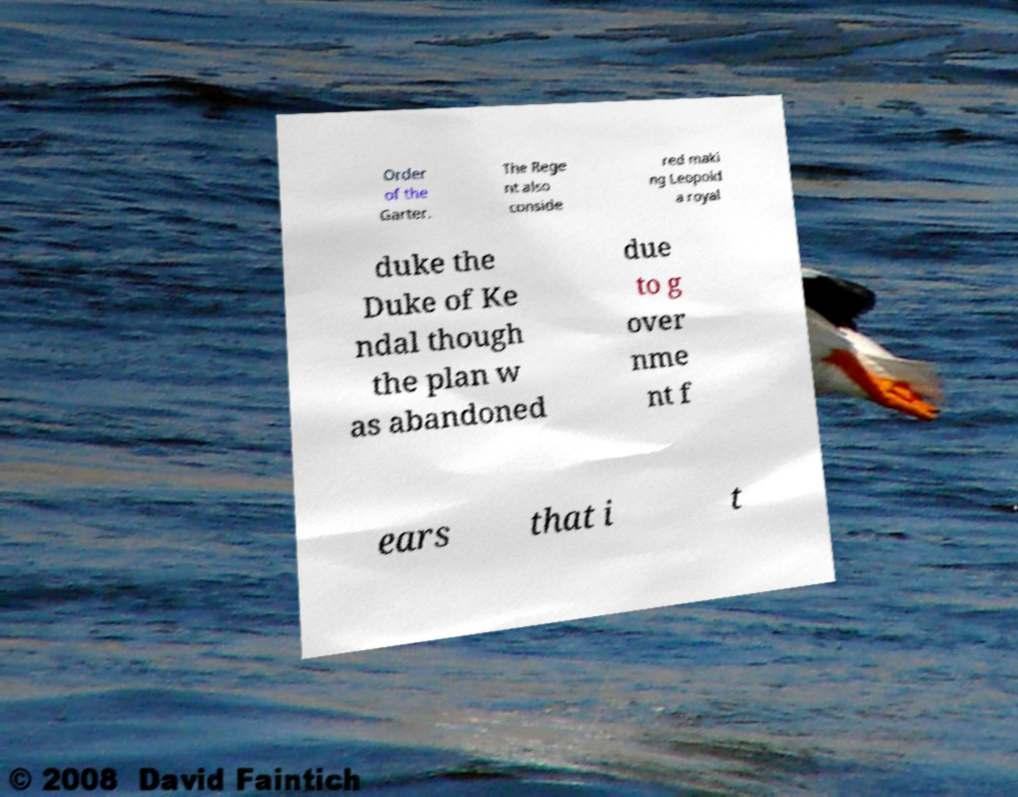Can you read and provide the text displayed in the image?This photo seems to have some interesting text. Can you extract and type it out for me? Order of the Garter. The Rege nt also conside red maki ng Leopold a royal duke the Duke of Ke ndal though the plan w as abandoned due to g over nme nt f ears that i t 